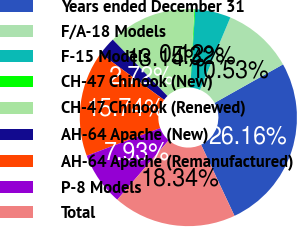<chart> <loc_0><loc_0><loc_500><loc_500><pie_chart><fcel>Years ended December 31<fcel>F/A-18 Models<fcel>F-15 Models<fcel>CH-47 Chinook (New)<fcel>CH-47 Chinook (Renewed)<fcel>AH-64 Apache (New)<fcel>AH-64 Apache (Remanufactured)<fcel>P-8 Models<fcel>Total<nl><fcel>26.16%<fcel>10.53%<fcel>5.32%<fcel>0.12%<fcel>13.14%<fcel>2.72%<fcel>15.74%<fcel>7.93%<fcel>18.34%<nl></chart> 